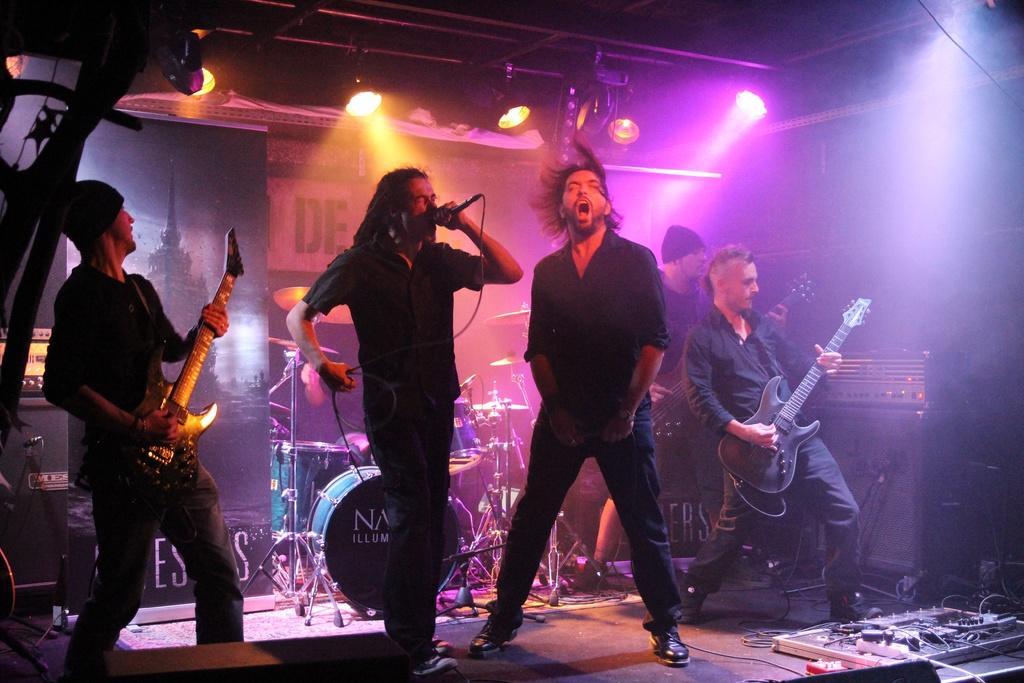Could you give a brief overview of what you see in this image? Here we can see a person standing on the stage and singing, and holding a microphone in his hands, and at side a person is standing, and here a person is playing the guitar, and at back her are the musical drums and at above here are the lights. 